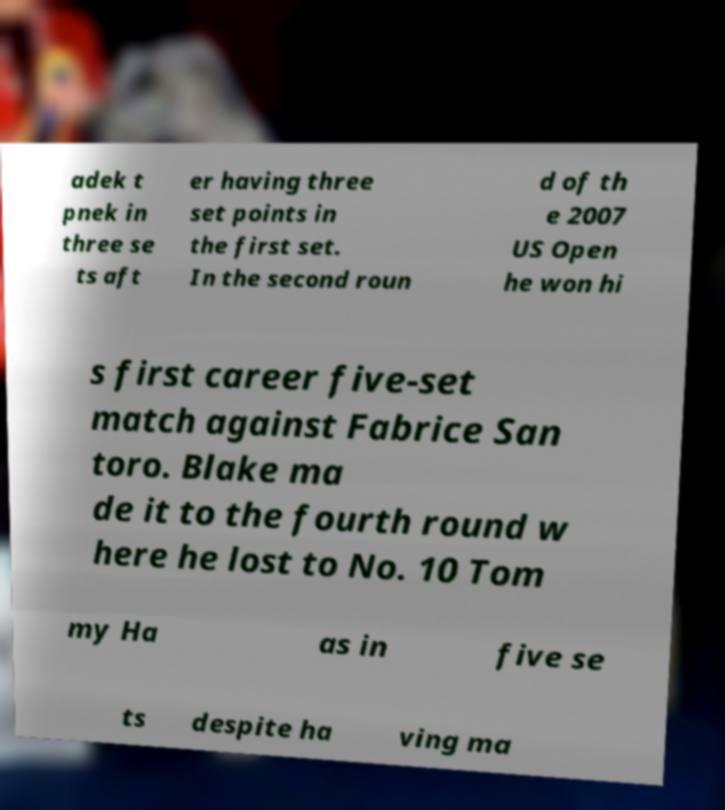Could you assist in decoding the text presented in this image and type it out clearly? adek t pnek in three se ts aft er having three set points in the first set. In the second roun d of th e 2007 US Open he won hi s first career five-set match against Fabrice San toro. Blake ma de it to the fourth round w here he lost to No. 10 Tom my Ha as in five se ts despite ha ving ma 